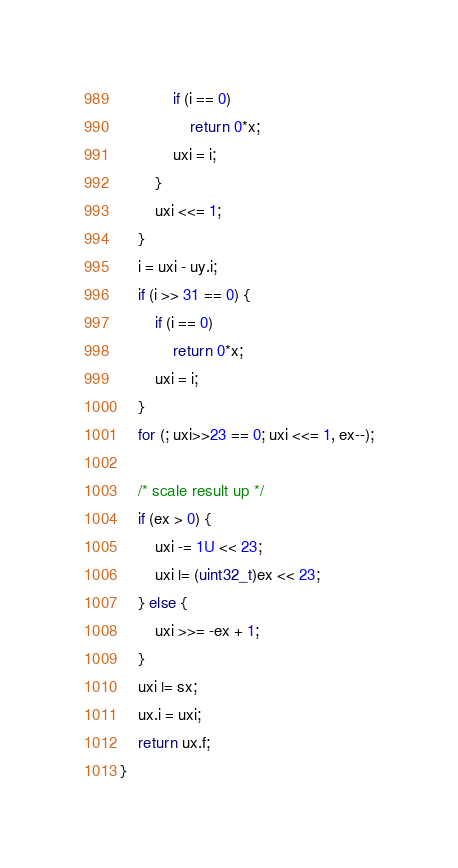Convert code to text. <code><loc_0><loc_0><loc_500><loc_500><_C_>			if (i == 0)
				return 0*x;
			uxi = i;
		}
		uxi <<= 1;
	}
	i = uxi - uy.i;
	if (i >> 31 == 0) {
		if (i == 0)
			return 0*x;
		uxi = i;
	}
	for (; uxi>>23 == 0; uxi <<= 1, ex--);

	/* scale result up */
	if (ex > 0) {
		uxi -= 1U << 23;
		uxi |= (uint32_t)ex << 23;
	} else {
		uxi >>= -ex + 1;
	}
	uxi |= sx;
	ux.i = uxi;
	return ux.f;
}
</code> 